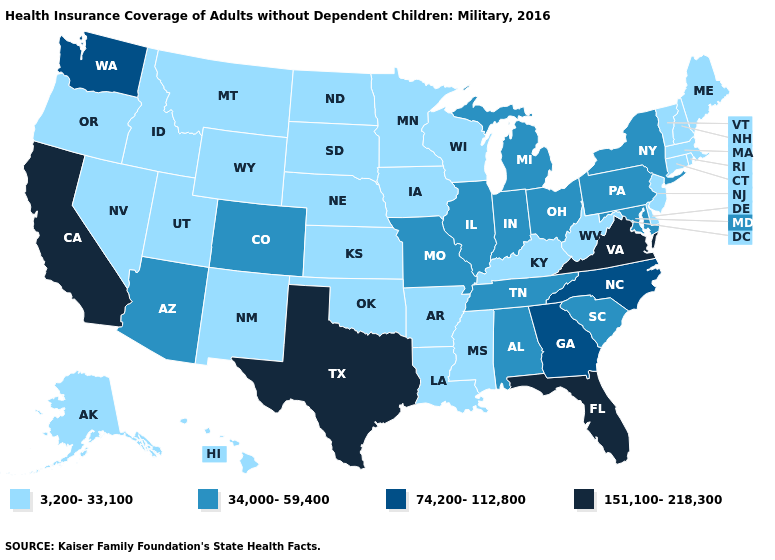What is the highest value in the Northeast ?
Concise answer only. 34,000-59,400. What is the value of Oregon?
Answer briefly. 3,200-33,100. Among the states that border Delaware , which have the lowest value?
Answer briefly. New Jersey. What is the value of Colorado?
Write a very short answer. 34,000-59,400. What is the value of Hawaii?
Quick response, please. 3,200-33,100. Name the states that have a value in the range 151,100-218,300?
Keep it brief. California, Florida, Texas, Virginia. Which states have the lowest value in the West?
Quick response, please. Alaska, Hawaii, Idaho, Montana, Nevada, New Mexico, Oregon, Utah, Wyoming. Name the states that have a value in the range 74,200-112,800?
Short answer required. Georgia, North Carolina, Washington. Name the states that have a value in the range 3,200-33,100?
Give a very brief answer. Alaska, Arkansas, Connecticut, Delaware, Hawaii, Idaho, Iowa, Kansas, Kentucky, Louisiana, Maine, Massachusetts, Minnesota, Mississippi, Montana, Nebraska, Nevada, New Hampshire, New Jersey, New Mexico, North Dakota, Oklahoma, Oregon, Rhode Island, South Dakota, Utah, Vermont, West Virginia, Wisconsin, Wyoming. What is the value of Texas?
Be succinct. 151,100-218,300. Is the legend a continuous bar?
Be succinct. No. Does Mississippi have the lowest value in the South?
Write a very short answer. Yes. Name the states that have a value in the range 34,000-59,400?
Concise answer only. Alabama, Arizona, Colorado, Illinois, Indiana, Maryland, Michigan, Missouri, New York, Ohio, Pennsylvania, South Carolina, Tennessee. Among the states that border Idaho , which have the lowest value?
Keep it brief. Montana, Nevada, Oregon, Utah, Wyoming. Name the states that have a value in the range 3,200-33,100?
Give a very brief answer. Alaska, Arkansas, Connecticut, Delaware, Hawaii, Idaho, Iowa, Kansas, Kentucky, Louisiana, Maine, Massachusetts, Minnesota, Mississippi, Montana, Nebraska, Nevada, New Hampshire, New Jersey, New Mexico, North Dakota, Oklahoma, Oregon, Rhode Island, South Dakota, Utah, Vermont, West Virginia, Wisconsin, Wyoming. 